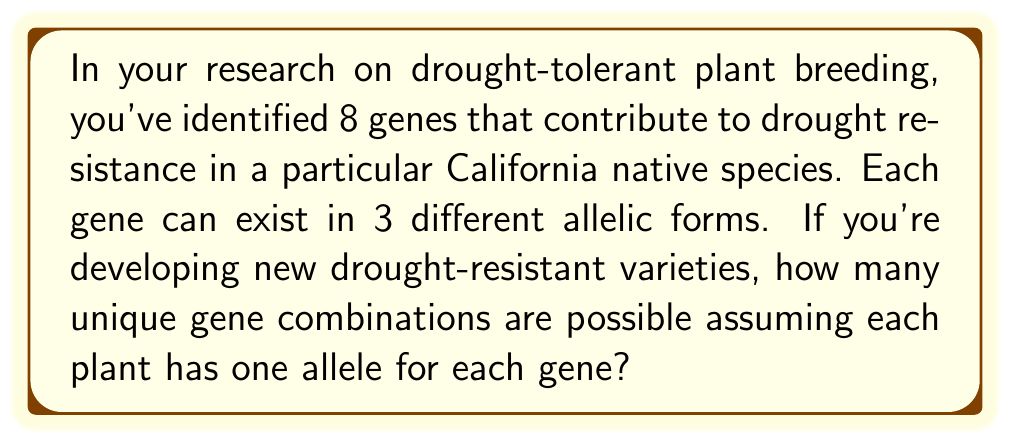Can you answer this question? Let's approach this step-by-step:

1) We have 8 genes, and each gene can exist in 3 different forms (alleles).

2) For each gene, we need to choose one of the 3 alleles. This is a case of making independent choices for each gene.

3) When we have independent choices, we multiply the number of options for each choice.

4) In this case, we have 8 independent choices (one for each gene), and each choice has 3 options (the 3 allelic forms).

5) Therefore, we can use the multiplication principle of counting.

6) The total number of unique gene combinations is:

   $$3 \times 3 \times 3 \times 3 \times 3 \times 3 \times 3 \times 3 = 3^8$$

7) We can calculate this:
   
   $$3^8 = 6,561$$

This result represents all possible unique combinations of alleles across the 8 genes, where each gene has one of its 3 possible allelic forms.
Answer: 6,561 unique gene combinations 